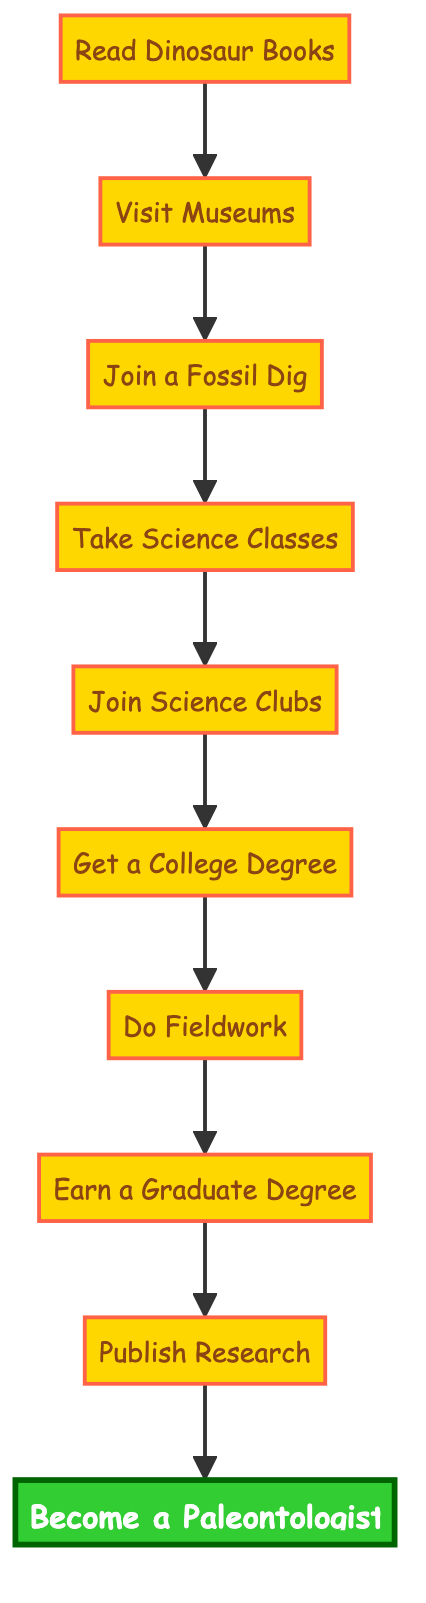What is the first step to become a paleontologist? The diagram starts with the node labeled "Read Dinosaur Books," indicating that this is the first step in the process.
Answer: Read Dinosaur Books How many steps are there in total? By counting the nodes in the diagram, we can see there are a total of 10 steps that lead from the first action to the final goal.
Answer: 10 What step comes right after "Join Science Clubs"? The diagram shows that the step following "Join Science Clubs" is "Get a College Degree," which is connected directly by an arrow.
Answer: Get a College Degree What is the final step in becoming a paleontologist? The end of the flow chart indicates that the last step is "Become a Paleontologist." This is the ultimate goal of the entire process.
Answer: Become a Paleontologist Which step involves experience with real fossils? "Visit Museums" is the step that involves experiencing real fossils, as indicated in the description connected to that node.
Answer: Visit Museums What step follows "Do Fieldwork"? The diagram flows from "Do Fieldwork" to "Earn a Graduate Degree," showing that graduate studies come after gaining experience in the field.
Answer: Earn a Graduate Degree Is "Publish Research" before or after "Join a Fossil Dig"? By following the flow chart, "Publish Research" is clearly shown to be after "Join a Fossil Dig," indicating that publishing comes later in the process.
Answer: After What is needed to get a college degree? The diagram doesn't specify directly, but it implies that one must first complete "Take Science Classes" to be prepared for college education leading to a degree.
Answer: Take Science Classes In what order do you visit museums and join a fossil dig? The flowchart shows that "Visit Museums" comes first, followed by "Join a Fossil Dig," demonstrating the sequence of these experiences.
Answer: Visit Museums, then Join a Fossil Dig 